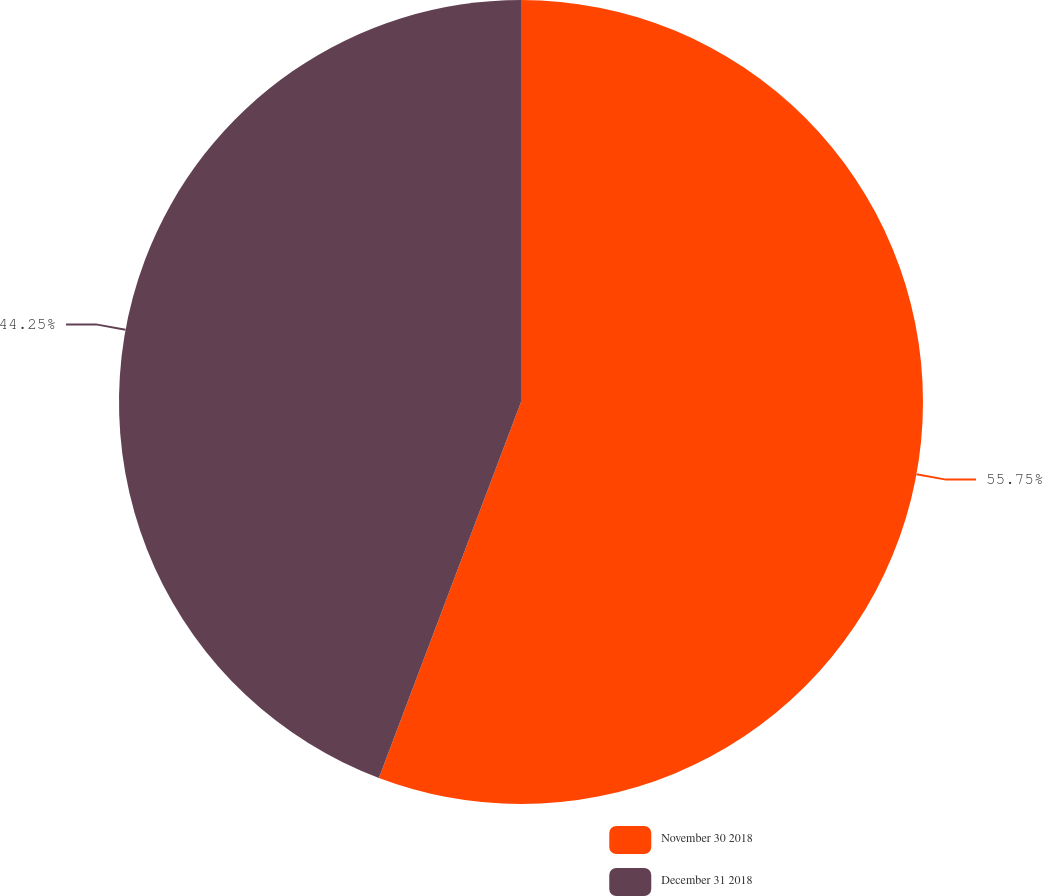<chart> <loc_0><loc_0><loc_500><loc_500><pie_chart><fcel>November 30 2018<fcel>December 31 2018<nl><fcel>55.75%<fcel>44.25%<nl></chart> 